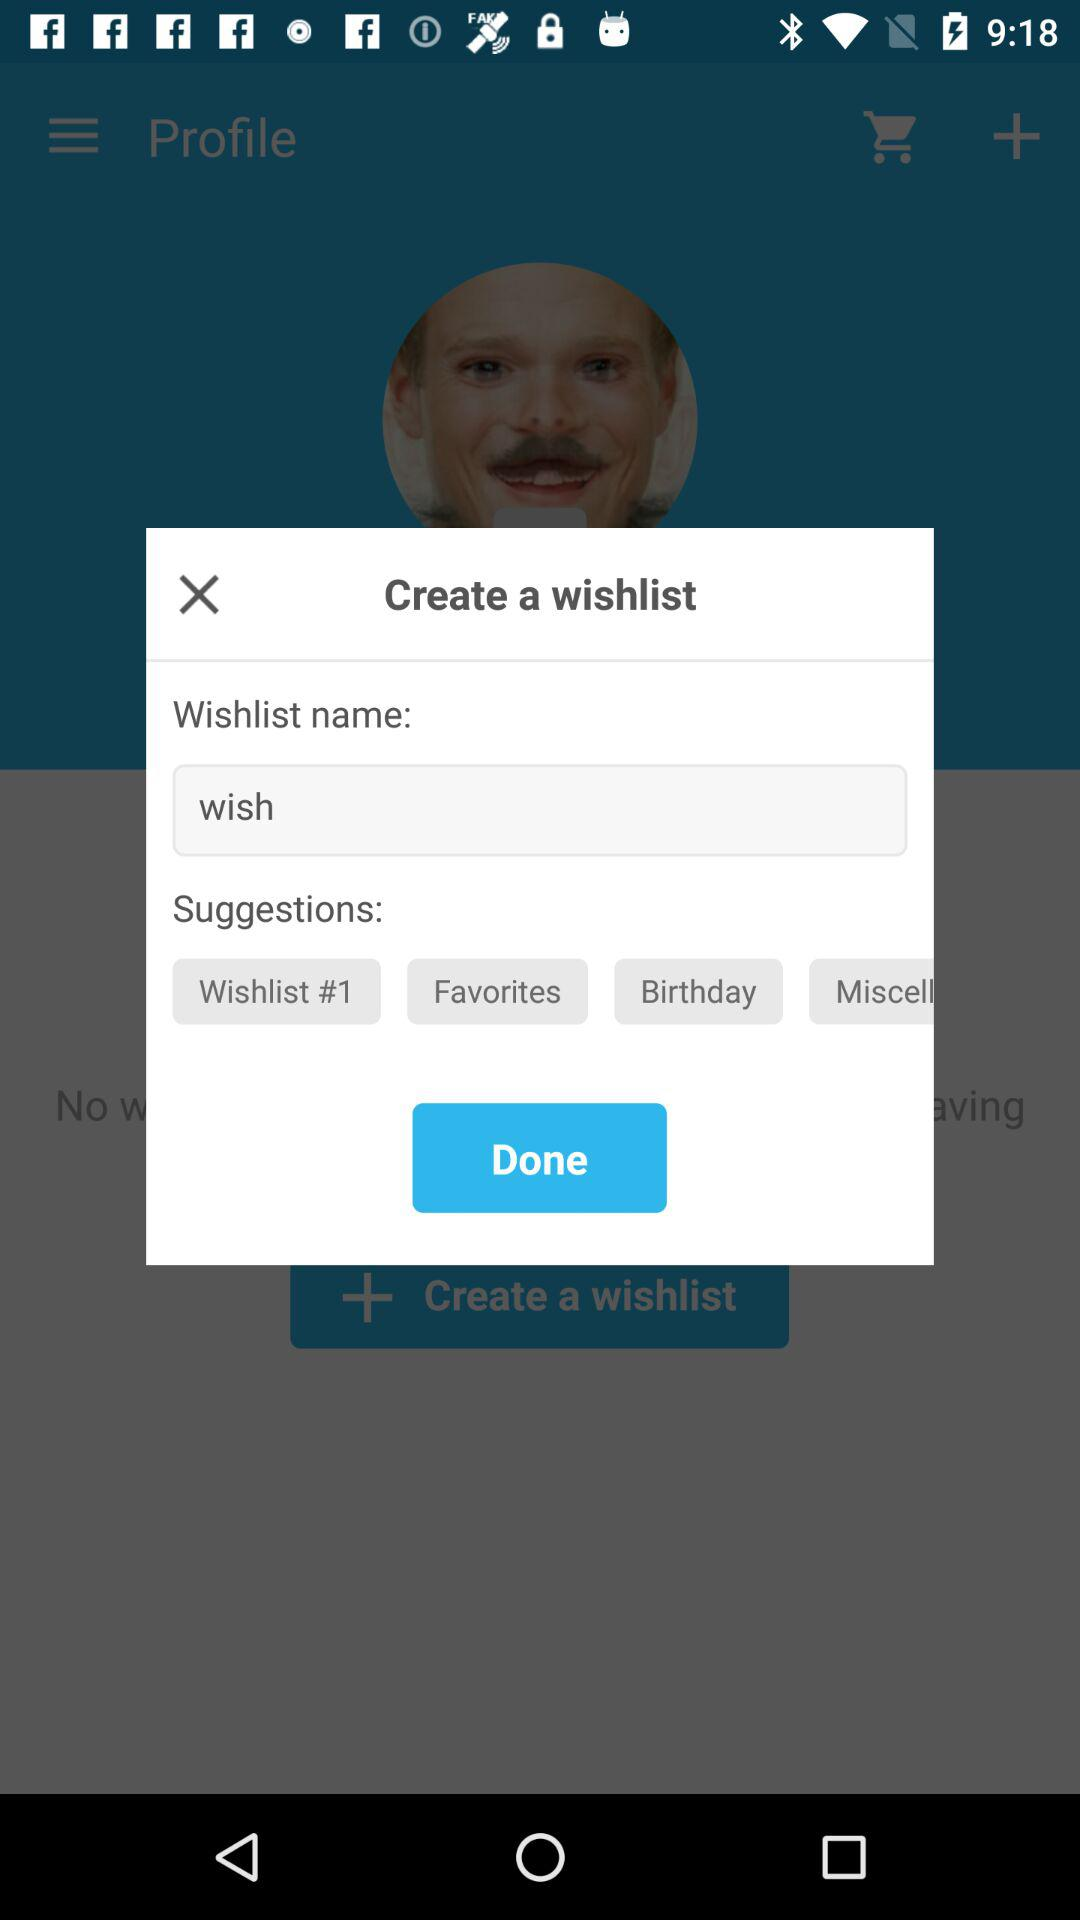What are the different suggestions shown for the wishlist name? The different suggestions shown for the wishlist name are "Wishlist #1", "Favorites" and "Birthday". 